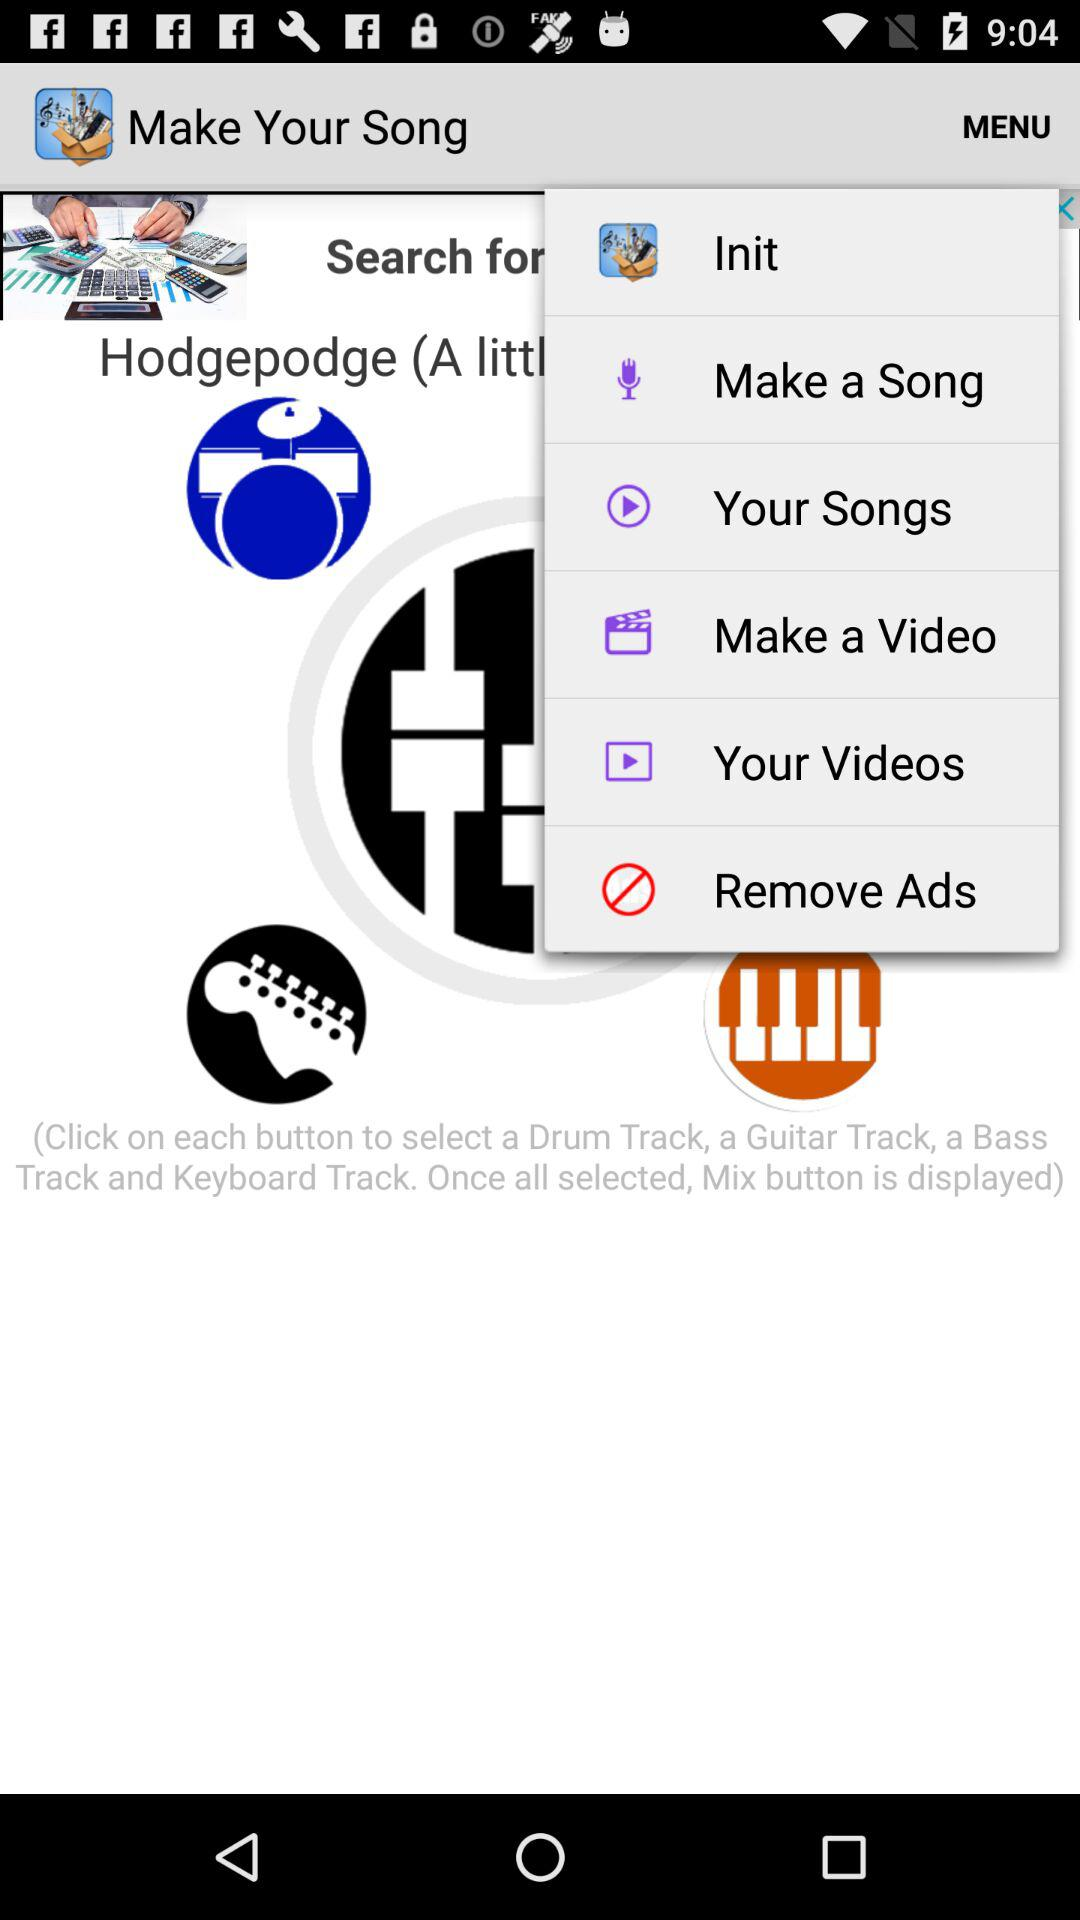What is the name of the application? The name of the application is "Make Your Song". 